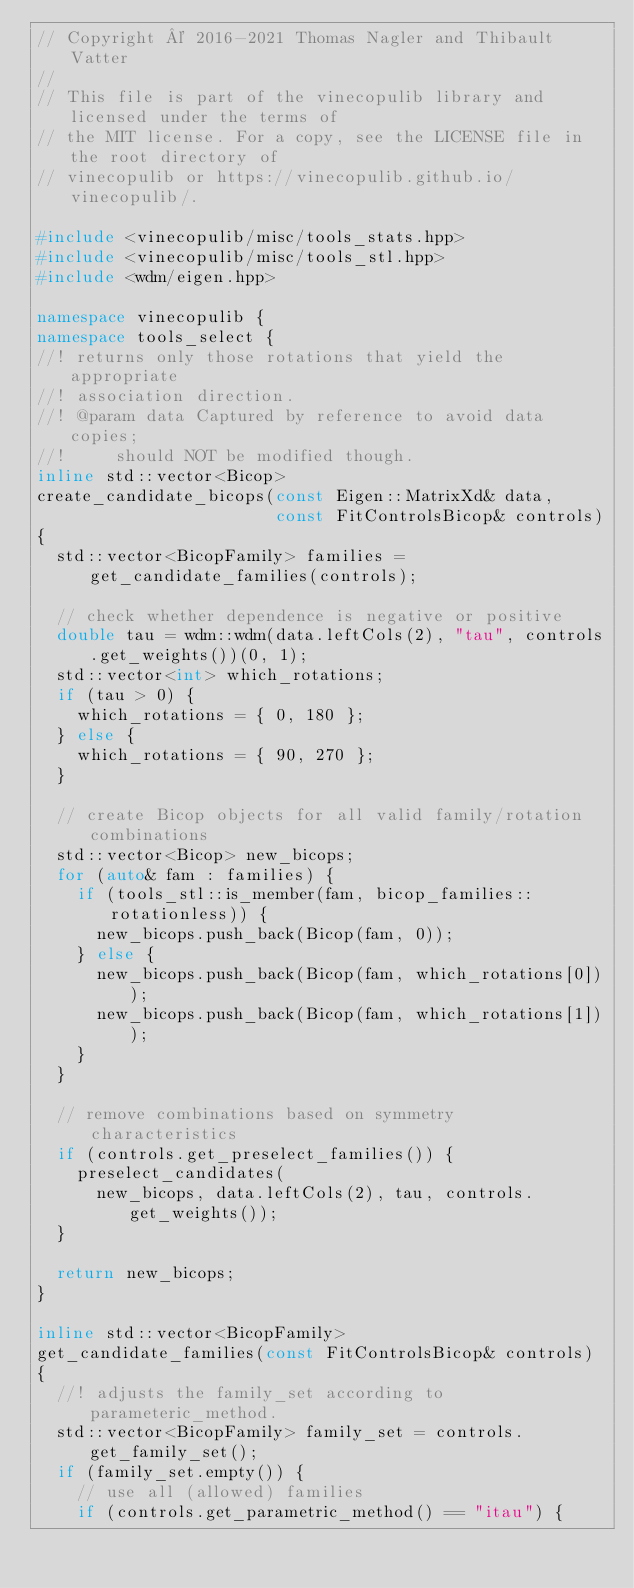<code> <loc_0><loc_0><loc_500><loc_500><_C++_>// Copyright © 2016-2021 Thomas Nagler and Thibault Vatter
//
// This file is part of the vinecopulib library and licensed under the terms of
// the MIT license. For a copy, see the LICENSE file in the root directory of
// vinecopulib or https://vinecopulib.github.io/vinecopulib/.

#include <vinecopulib/misc/tools_stats.hpp>
#include <vinecopulib/misc/tools_stl.hpp>
#include <wdm/eigen.hpp>

namespace vinecopulib {
namespace tools_select {
//! returns only those rotations that yield the appropriate
//! association direction.
//! @param data Captured by reference to avoid data copies;
//!     should NOT be modified though.
inline std::vector<Bicop>
create_candidate_bicops(const Eigen::MatrixXd& data,
                        const FitControlsBicop& controls)
{
  std::vector<BicopFamily> families = get_candidate_families(controls);

  // check whether dependence is negative or positive
  double tau = wdm::wdm(data.leftCols(2), "tau", controls.get_weights())(0, 1);
  std::vector<int> which_rotations;
  if (tau > 0) {
    which_rotations = { 0, 180 };
  } else {
    which_rotations = { 90, 270 };
  }

  // create Bicop objects for all valid family/rotation combinations
  std::vector<Bicop> new_bicops;
  for (auto& fam : families) {
    if (tools_stl::is_member(fam, bicop_families::rotationless)) {
      new_bicops.push_back(Bicop(fam, 0));
    } else {
      new_bicops.push_back(Bicop(fam, which_rotations[0]));
      new_bicops.push_back(Bicop(fam, which_rotations[1]));
    }
  }

  // remove combinations based on symmetry characteristics
  if (controls.get_preselect_families()) {
    preselect_candidates(
      new_bicops, data.leftCols(2), tau, controls.get_weights());
  }

  return new_bicops;
}

inline std::vector<BicopFamily>
get_candidate_families(const FitControlsBicop& controls)
{
  //! adjusts the family_set according to parameteric_method.
  std::vector<BicopFamily> family_set = controls.get_family_set();
  if (family_set.empty()) {
    // use all (allowed) families
    if (controls.get_parametric_method() == "itau") {</code> 